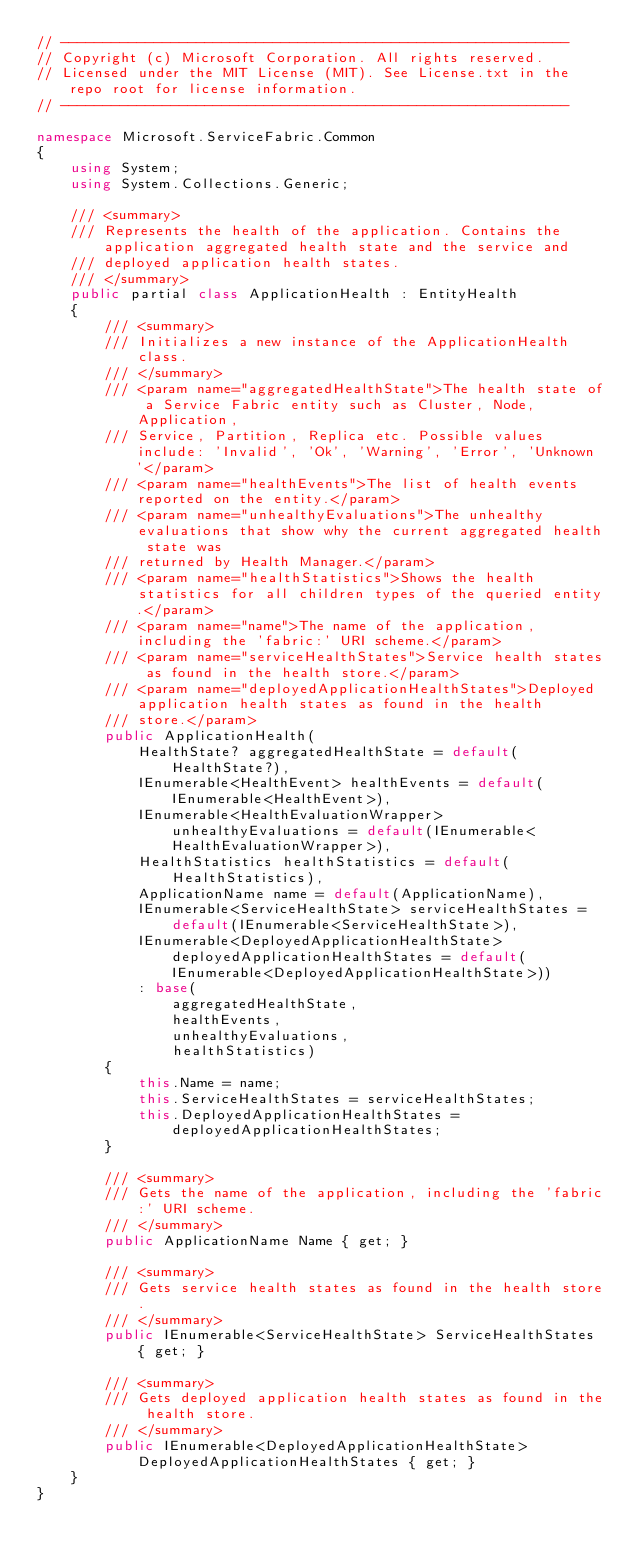Convert code to text. <code><loc_0><loc_0><loc_500><loc_500><_C#_>// ------------------------------------------------------------
// Copyright (c) Microsoft Corporation. All rights reserved.
// Licensed under the MIT License (MIT). See License.txt in the repo root for license information.
// ------------------------------------------------------------

namespace Microsoft.ServiceFabric.Common
{
    using System;
    using System.Collections.Generic;

    /// <summary>
    /// Represents the health of the application. Contains the application aggregated health state and the service and
    /// deployed application health states.
    /// </summary>
    public partial class ApplicationHealth : EntityHealth
    {
        /// <summary>
        /// Initializes a new instance of the ApplicationHealth class.
        /// </summary>
        /// <param name="aggregatedHealthState">The health state of a Service Fabric entity such as Cluster, Node, Application,
        /// Service, Partition, Replica etc. Possible values include: 'Invalid', 'Ok', 'Warning', 'Error', 'Unknown'</param>
        /// <param name="healthEvents">The list of health events reported on the entity.</param>
        /// <param name="unhealthyEvaluations">The unhealthy evaluations that show why the current aggregated health state was
        /// returned by Health Manager.</param>
        /// <param name="healthStatistics">Shows the health statistics for all children types of the queried entity.</param>
        /// <param name="name">The name of the application, including the 'fabric:' URI scheme.</param>
        /// <param name="serviceHealthStates">Service health states as found in the health store.</param>
        /// <param name="deployedApplicationHealthStates">Deployed application health states as found in the health
        /// store.</param>
        public ApplicationHealth(
            HealthState? aggregatedHealthState = default(HealthState?),
            IEnumerable<HealthEvent> healthEvents = default(IEnumerable<HealthEvent>),
            IEnumerable<HealthEvaluationWrapper> unhealthyEvaluations = default(IEnumerable<HealthEvaluationWrapper>),
            HealthStatistics healthStatistics = default(HealthStatistics),
            ApplicationName name = default(ApplicationName),
            IEnumerable<ServiceHealthState> serviceHealthStates = default(IEnumerable<ServiceHealthState>),
            IEnumerable<DeployedApplicationHealthState> deployedApplicationHealthStates = default(IEnumerable<DeployedApplicationHealthState>))
            : base(
                aggregatedHealthState,
                healthEvents,
                unhealthyEvaluations,
                healthStatistics)
        {
            this.Name = name;
            this.ServiceHealthStates = serviceHealthStates;
            this.DeployedApplicationHealthStates = deployedApplicationHealthStates;
        }

        /// <summary>
        /// Gets the name of the application, including the 'fabric:' URI scheme.
        /// </summary>
        public ApplicationName Name { get; }

        /// <summary>
        /// Gets service health states as found in the health store.
        /// </summary>
        public IEnumerable<ServiceHealthState> ServiceHealthStates { get; }

        /// <summary>
        /// Gets deployed application health states as found in the health store.
        /// </summary>
        public IEnumerable<DeployedApplicationHealthState> DeployedApplicationHealthStates { get; }
    }
}
</code> 